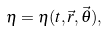Convert formula to latex. <formula><loc_0><loc_0><loc_500><loc_500>\eta = \eta ( t , \vec { r } , \vec { \theta } ) ,</formula> 